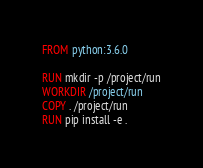<code> <loc_0><loc_0><loc_500><loc_500><_Dockerfile_>FROM python:3.6.0

RUN mkdir -p /project/run
WORKDIR /project/run
COPY . /project/run
RUN pip install -e .
</code> 